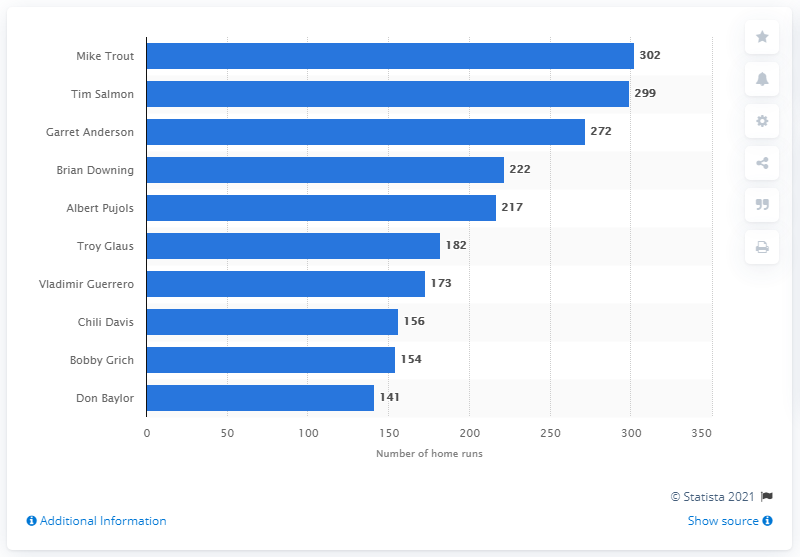Specify some key components in this picture. The individual who has recorded the highest number of home runs in the history of the Los Angeles Angels franchise is Mike Trout. Mike Trout has hit a total of 302 home runs. 